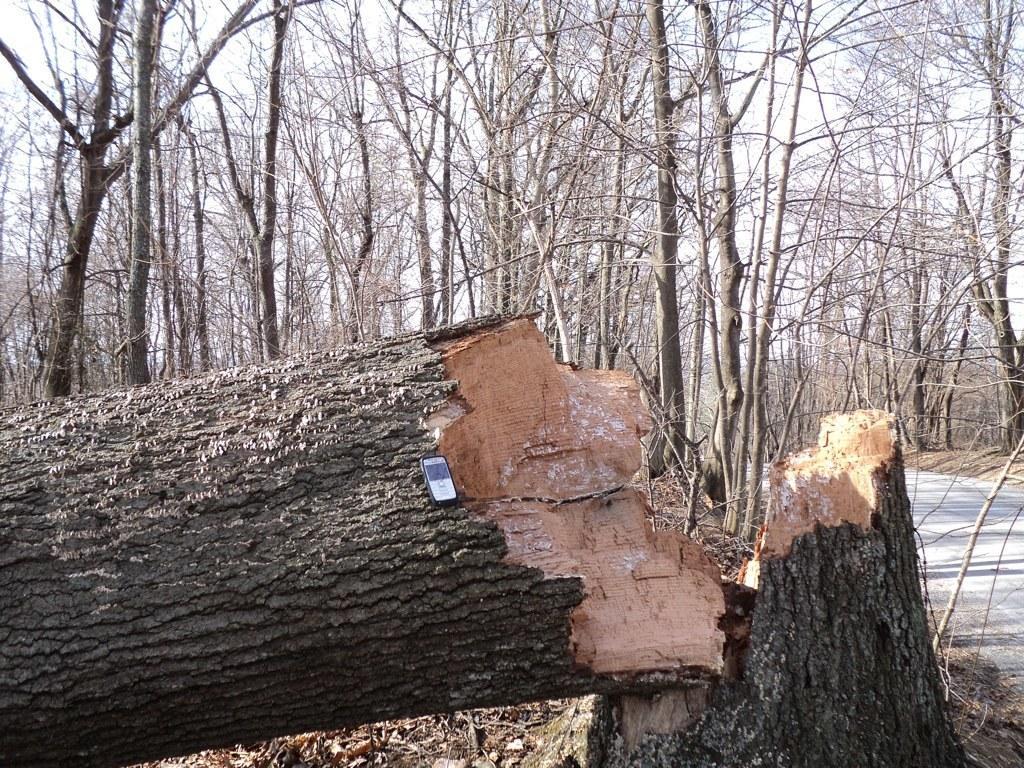In one or two sentences, can you explain what this image depicts? In this image we can see one cell phone on the tree, one road, so many trees, one tree stump, some dried leaves on the surface, one cut wooden tree, and at the top there is the sky. 